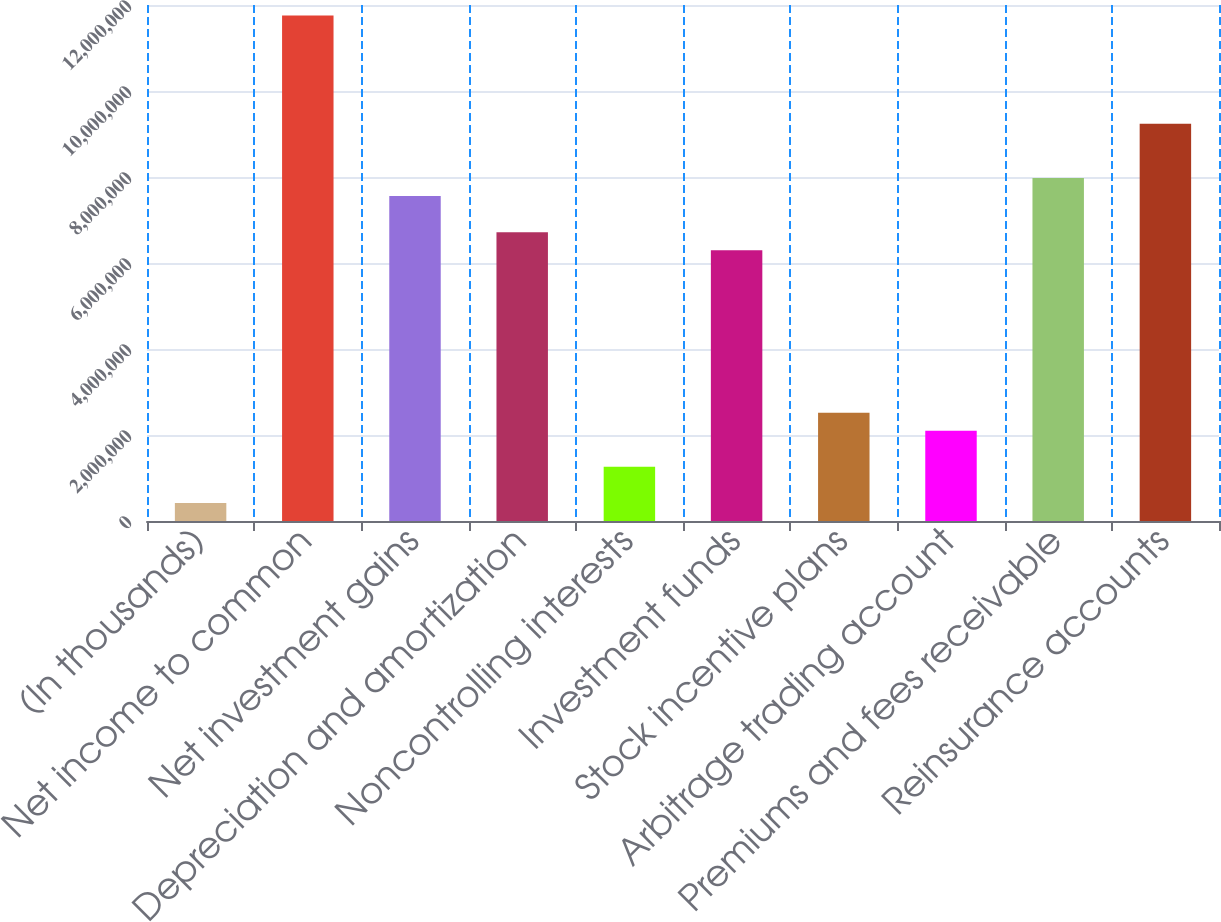<chart> <loc_0><loc_0><loc_500><loc_500><bar_chart><fcel>(In thousands)<fcel>Net income to common<fcel>Net investment gains<fcel>Depreciation and amortization<fcel>Noncontrolling interests<fcel>Investment funds<fcel>Stock incentive plans<fcel>Arbitrage trading account<fcel>Premiums and fees receivable<fcel>Reinsurance accounts<nl><fcel>419861<fcel>1.17547e+07<fcel>7.5566e+06<fcel>6.71698e+06<fcel>1.25948e+06<fcel>6.29718e+06<fcel>2.5189e+06<fcel>2.09909e+06<fcel>7.97641e+06<fcel>9.23583e+06<nl></chart> 